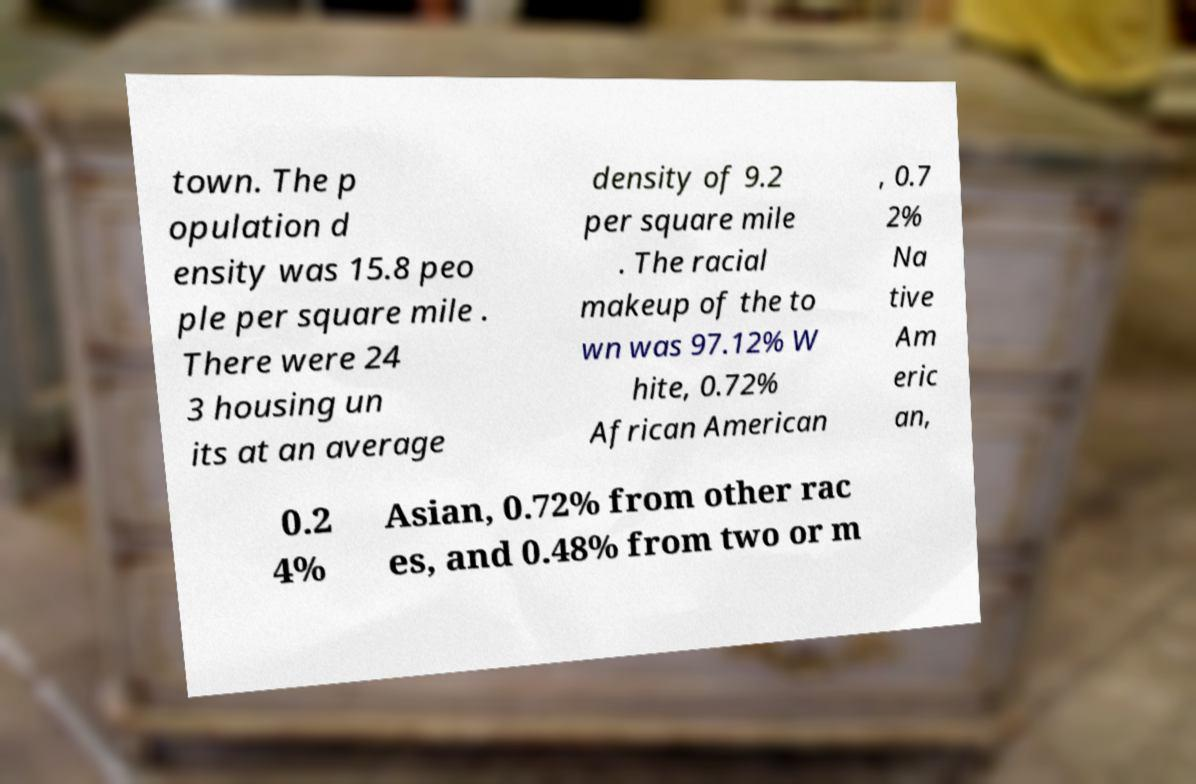Please identify and transcribe the text found in this image. town. The p opulation d ensity was 15.8 peo ple per square mile . There were 24 3 housing un its at an average density of 9.2 per square mile . The racial makeup of the to wn was 97.12% W hite, 0.72% African American , 0.7 2% Na tive Am eric an, 0.2 4% Asian, 0.72% from other rac es, and 0.48% from two or m 